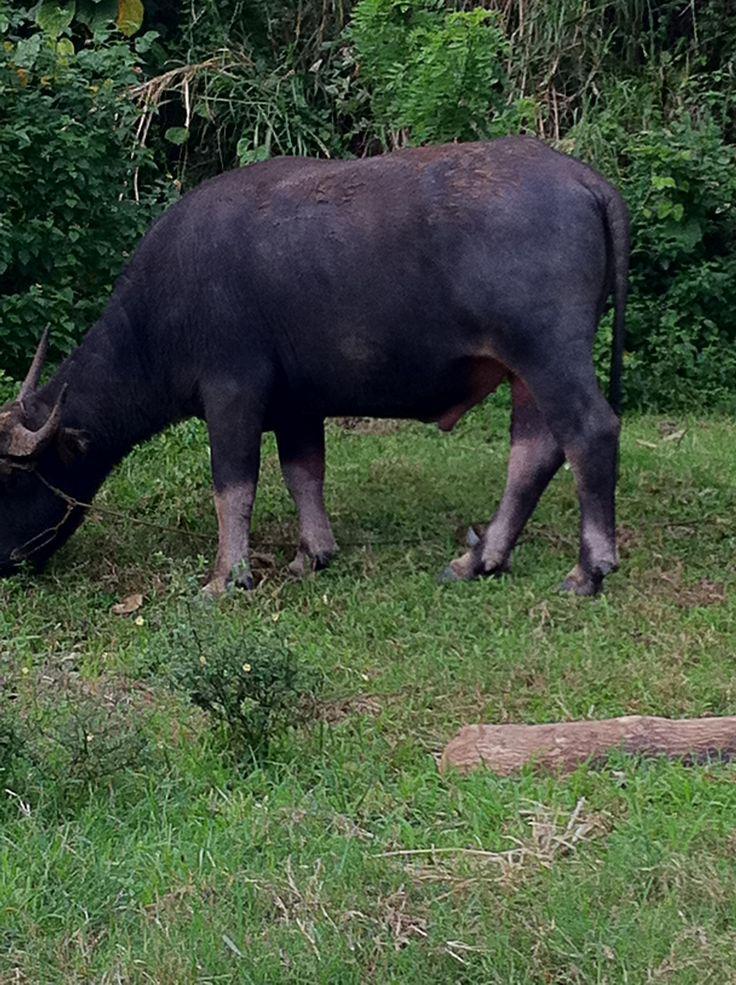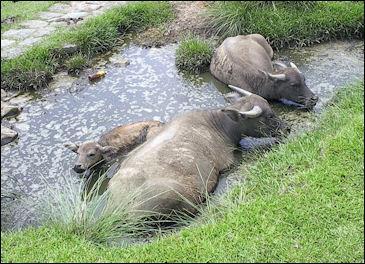The first image is the image on the left, the second image is the image on the right. Examine the images to the left and right. Is the description "The cow in the image on the left is walking through the water." accurate? Answer yes or no. No. The first image is the image on the left, the second image is the image on the right. Examine the images to the left and right. Is the description "One image features one horned animal standing in muddy water with its body turned leftward, and the other image features multiple hooved animals surrounded by greenery." accurate? Answer yes or no. No. 